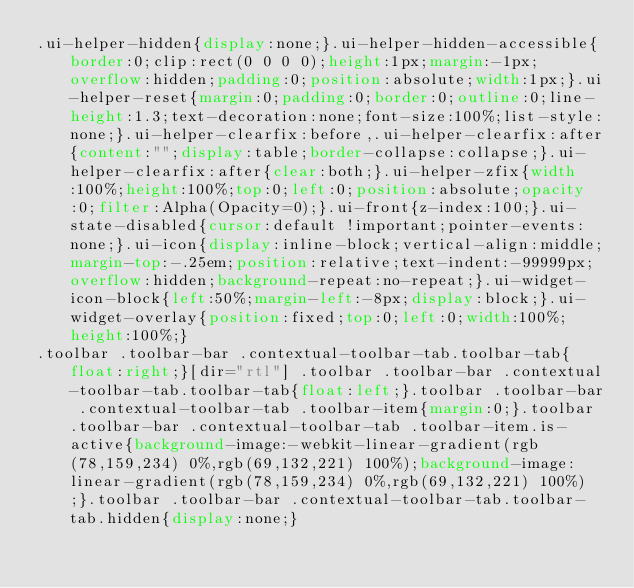Convert code to text. <code><loc_0><loc_0><loc_500><loc_500><_CSS_>.ui-helper-hidden{display:none;}.ui-helper-hidden-accessible{border:0;clip:rect(0 0 0 0);height:1px;margin:-1px;overflow:hidden;padding:0;position:absolute;width:1px;}.ui-helper-reset{margin:0;padding:0;border:0;outline:0;line-height:1.3;text-decoration:none;font-size:100%;list-style:none;}.ui-helper-clearfix:before,.ui-helper-clearfix:after{content:"";display:table;border-collapse:collapse;}.ui-helper-clearfix:after{clear:both;}.ui-helper-zfix{width:100%;height:100%;top:0;left:0;position:absolute;opacity:0;filter:Alpha(Opacity=0);}.ui-front{z-index:100;}.ui-state-disabled{cursor:default !important;pointer-events:none;}.ui-icon{display:inline-block;vertical-align:middle;margin-top:-.25em;position:relative;text-indent:-99999px;overflow:hidden;background-repeat:no-repeat;}.ui-widget-icon-block{left:50%;margin-left:-8px;display:block;}.ui-widget-overlay{position:fixed;top:0;left:0;width:100%;height:100%;}
.toolbar .toolbar-bar .contextual-toolbar-tab.toolbar-tab{float:right;}[dir="rtl"] .toolbar .toolbar-bar .contextual-toolbar-tab.toolbar-tab{float:left;}.toolbar .toolbar-bar .contextual-toolbar-tab .toolbar-item{margin:0;}.toolbar .toolbar-bar .contextual-toolbar-tab .toolbar-item.is-active{background-image:-webkit-linear-gradient(rgb(78,159,234) 0%,rgb(69,132,221) 100%);background-image:linear-gradient(rgb(78,159,234) 0%,rgb(69,132,221) 100%);}.toolbar .toolbar-bar .contextual-toolbar-tab.toolbar-tab.hidden{display:none;}</code> 